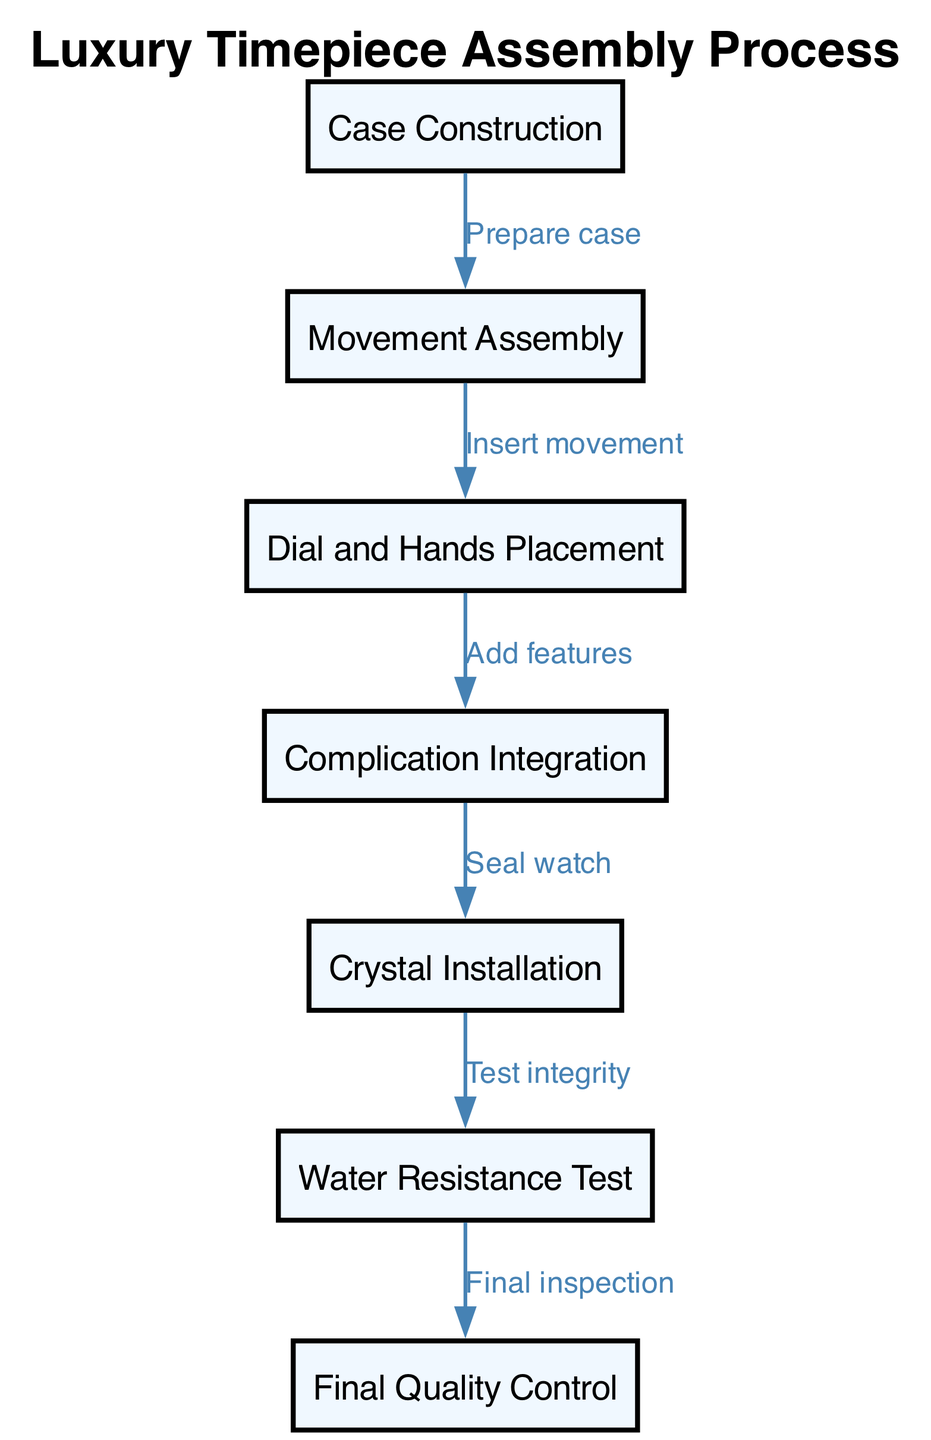What is the first step in the assembly process? The first node in the diagram lists "Case Construction" as the first step.
Answer: Case Construction How many nodes are in the diagram? Counting each of the nodes listed in the data, there are a total of seven steps shown.
Answer: 7 What is the last step in the assembly process? The last node in the diagram indicates "Final Quality Control" as the final step of the assembly process.
Answer: Final Quality Control What step comes after "Movement Assembly"? Referring to the flow from "Movement Assembly," the next step indicated in the diagram is "Dial and Hands Placement."
Answer: Dial and Hands Placement How many edges are used to connect the nodes? By counting the connections or edges between the steps in the diagram, there are six edges linking the nodes together.
Answer: 6 Which step integrates the complications? According to the flow of the diagram, "Complication Integration" is the step that focuses on adding additional features.
Answer: Complication Integration What step follows the "Water Resistance Test"? Looking at the preceding flows, the step that directly follows "Water Resistance Test" is "Final Quality Control."
Answer: Final Quality Control Which step involves sealing the watch? The diagram shows that "Seal watch" is associated with the step labeled "Complication Integration."
Answer: Complication Integration What is the relationship between "Dial and Hands Placement" and "Complication Integration"? The diagram indicates that "Add features" takes place between the "Dial and Hands Placement" and "Complication Integration," showing this sequential relationship.
Answer: Add features 